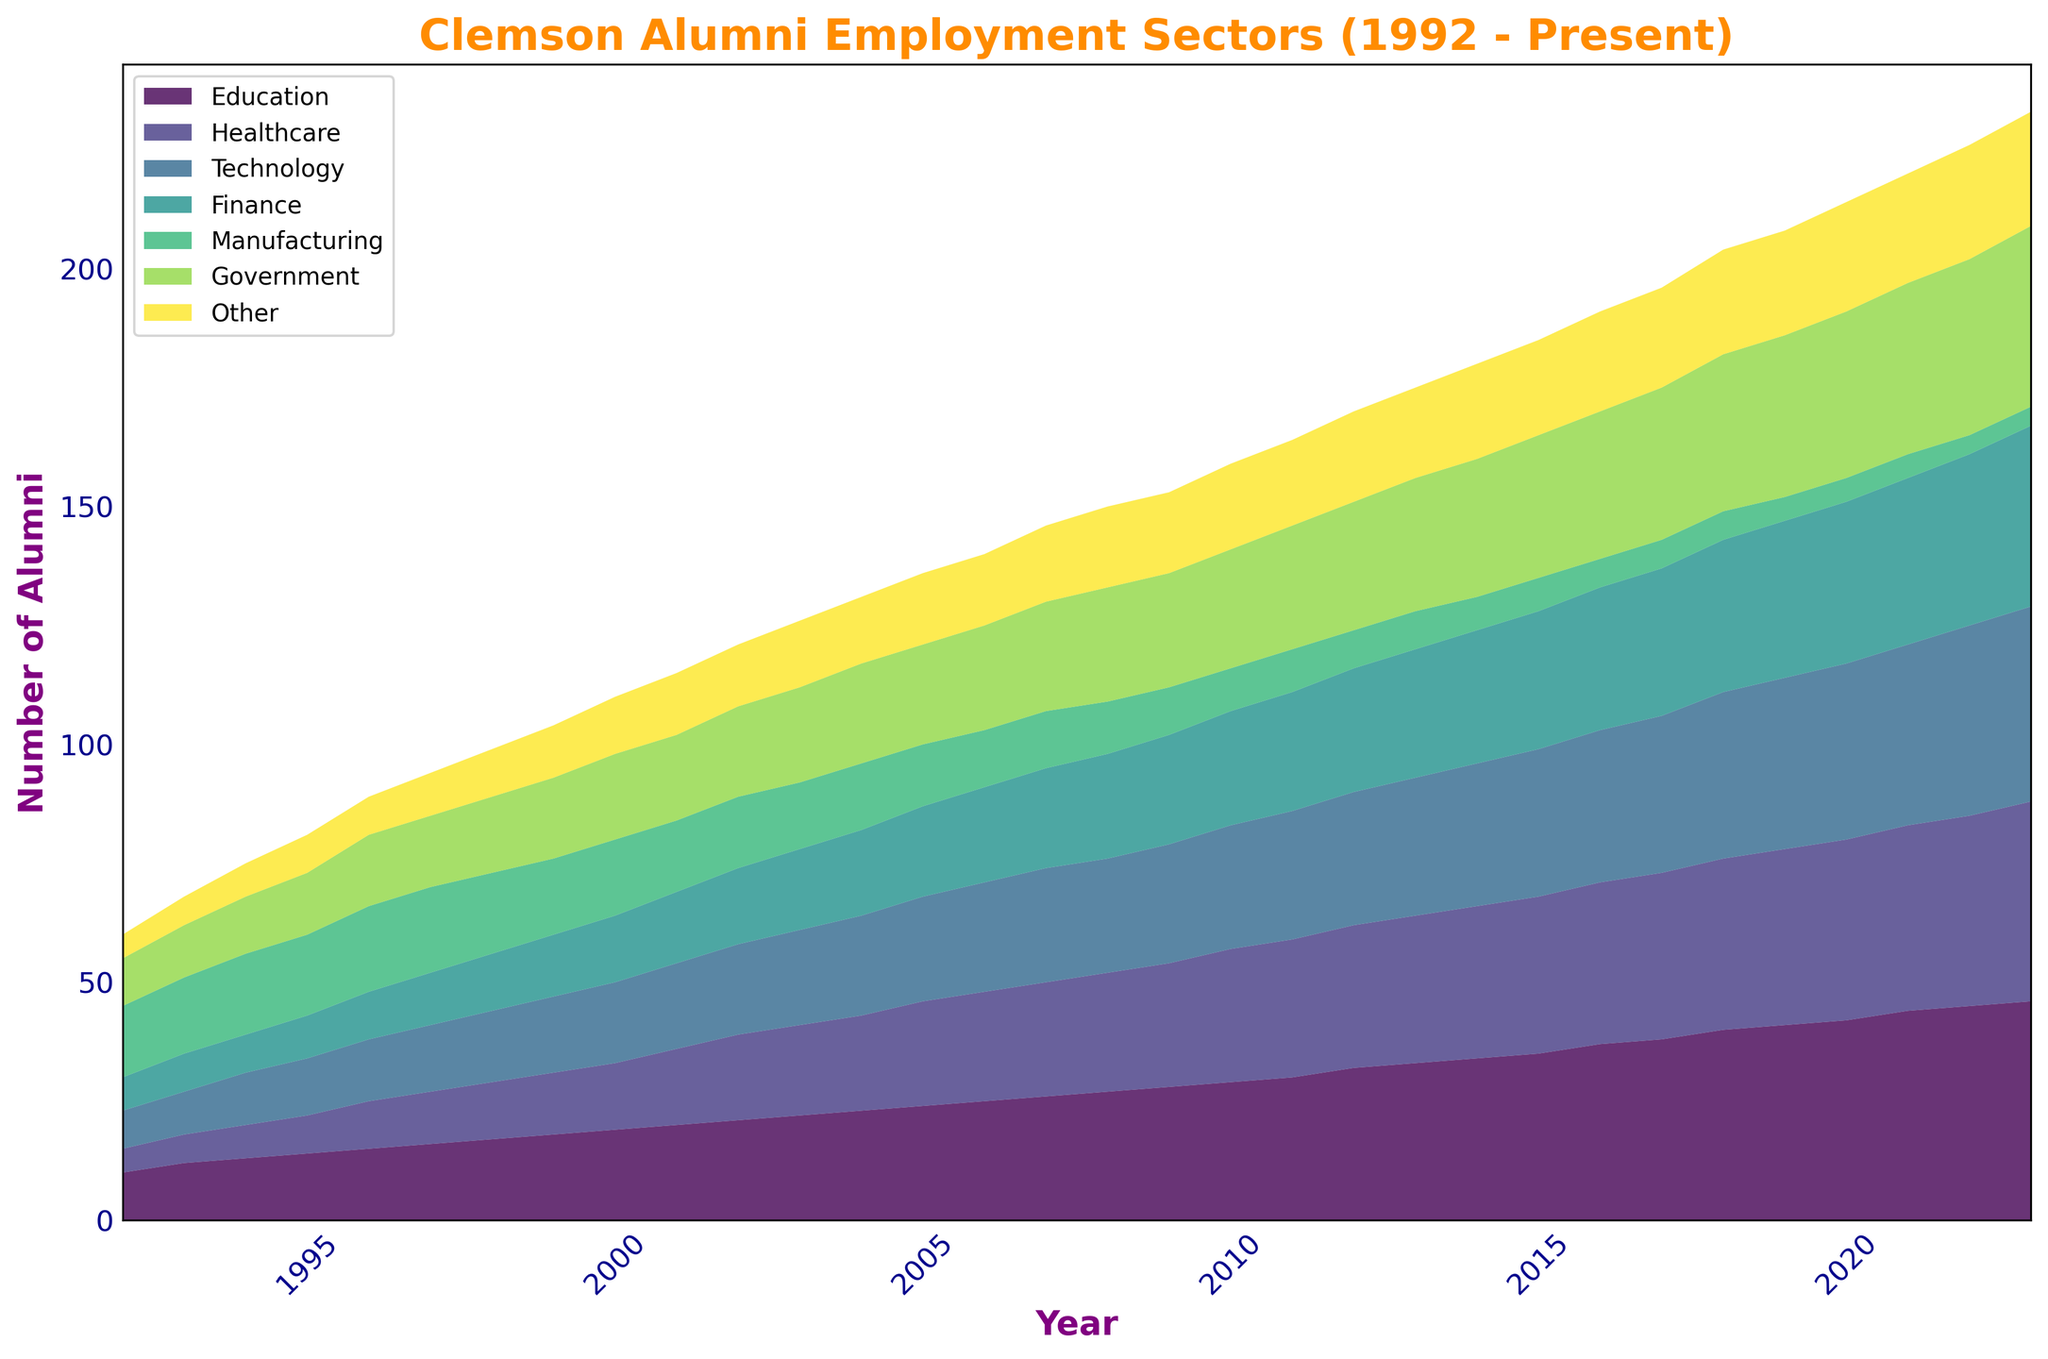What industry experienced the greatest increase in the number of Clemson alumni employed from 1992 to 2023? By comparing the values for each industry in 1992 and 2023, Education shows the largest increase, from 10 in 1992 to 46 in 2023, which is an increase of 36.
Answer: Education Between 2010 and 2020, which industry saw the least change in the number of Clemson alumni employed? By observing the area chart, the Manufacturing sector had minimal change, declining only slightly from 9 to 5 within those years.
Answer: Manufacturing What is the total number of Clemson alumni employed in 1992 across all sectors? Adding the numbers for all sectors in 1992 (10 + 5 + 8 + 7 + 15 + 10 + 5) gives a total of 60.
Answer: 60 By 2023, how does the number of Clemson alumni in Government compare to those in Technology? In 2023, Government has 38 alumni while Technology has 41 alumni. By comparison, Technology has more alumni than Government.
Answer: Technology How did the number of Clemson alumni employed in Finance change from 2000 to 2010? The area chart shows a gradual increase from 2000 with 14 alumni to 24 alumni in 2010, a total change of +10.
Answer: +10 In what year did the number of Clemson alumni in Healthcare surpass those in Manufacturing for the first time? By following the trend lines, Healthcare surpassed Manufacturing first in 2000, with Healthcare at 14 and Manufacturing at 16.
Answer: 2000 What is the combined total of Clemson alumni in the Technology and Finance sectors in 2023? Adding the values for Technology (41) and Finance (38) in 2023 gives a combined total of 79.
Answer: 79 Between 1992 and 2023, which sector had the most consistent growth in the number of Clemson alumni? Analyzing the trend lines, Education shows the most consistent growth, increasing steadily each year.
Answer: Education In 2005, how many more Clemson alumni were in the Education sector compared to the Government sector? In 2005, comparing values (24 in Education and 21 in Government), there were 3 more alumni in Education.
Answer: 3 Which sector had the most significant drop in the number of Clemson alumni employed from 1992 to 2023? Observing the trend, Manufacturing experienced a substantial decrease from 15 in 1992 to 4 in 2023, a drop of 11.
Answer: Manufacturing 